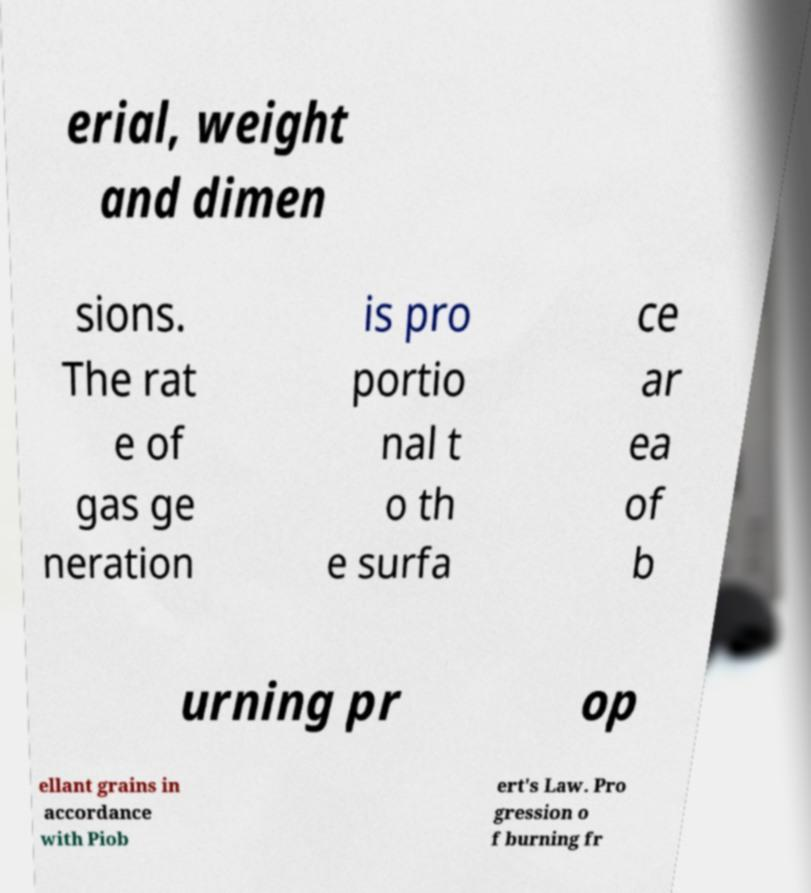Can you read and provide the text displayed in the image?This photo seems to have some interesting text. Can you extract and type it out for me? erial, weight and dimen sions. The rat e of gas ge neration is pro portio nal t o th e surfa ce ar ea of b urning pr op ellant grains in accordance with Piob ert's Law. Pro gression o f burning fr 